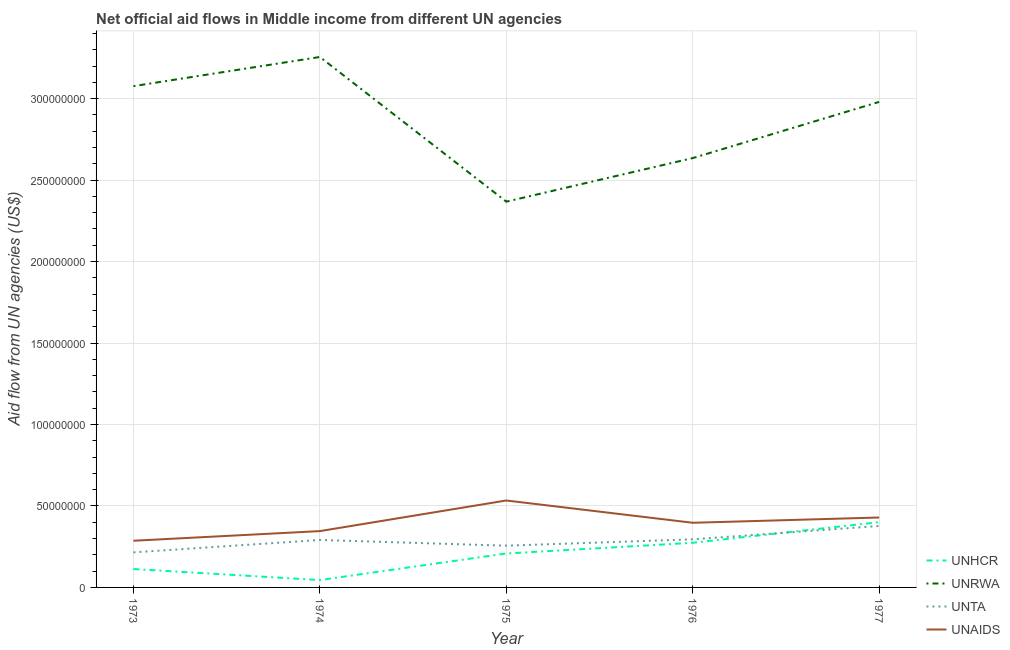How many different coloured lines are there?
Ensure brevity in your answer.  4. Does the line corresponding to amount of aid given by unrwa intersect with the line corresponding to amount of aid given by unhcr?
Offer a terse response. No. What is the amount of aid given by unta in 1975?
Offer a terse response. 2.56e+07. Across all years, what is the maximum amount of aid given by unta?
Give a very brief answer. 3.77e+07. Across all years, what is the minimum amount of aid given by unta?
Offer a very short reply. 2.15e+07. In which year was the amount of aid given by unta minimum?
Make the answer very short. 1973. What is the total amount of aid given by unrwa in the graph?
Offer a very short reply. 1.43e+09. What is the difference between the amount of aid given by unhcr in 1973 and that in 1975?
Make the answer very short. -9.52e+06. What is the difference between the amount of aid given by unaids in 1973 and the amount of aid given by unrwa in 1974?
Your response must be concise. -2.97e+08. What is the average amount of aid given by unrwa per year?
Make the answer very short. 2.86e+08. In the year 1975, what is the difference between the amount of aid given by unta and amount of aid given by unaids?
Your answer should be compact. -2.77e+07. In how many years, is the amount of aid given by unrwa greater than 40000000 US$?
Provide a short and direct response. 5. What is the ratio of the amount of aid given by unhcr in 1973 to that in 1977?
Give a very brief answer. 0.28. Is the amount of aid given by unrwa in 1973 less than that in 1977?
Make the answer very short. No. Is the difference between the amount of aid given by unta in 1975 and 1977 greater than the difference between the amount of aid given by unhcr in 1975 and 1977?
Your response must be concise. Yes. What is the difference between the highest and the second highest amount of aid given by unaids?
Make the answer very short. 1.04e+07. What is the difference between the highest and the lowest amount of aid given by unta?
Your answer should be very brief. 1.62e+07. Is the sum of the amount of aid given by unaids in 1973 and 1977 greater than the maximum amount of aid given by unrwa across all years?
Your response must be concise. No. Is it the case that in every year, the sum of the amount of aid given by unhcr and amount of aid given by unaids is greater than the sum of amount of aid given by unta and amount of aid given by unrwa?
Ensure brevity in your answer.  No. Is it the case that in every year, the sum of the amount of aid given by unhcr and amount of aid given by unrwa is greater than the amount of aid given by unta?
Offer a very short reply. Yes. Does the amount of aid given by unta monotonically increase over the years?
Offer a very short reply. No. Is the amount of aid given by unta strictly greater than the amount of aid given by unhcr over the years?
Provide a succinct answer. No. What is the difference between two consecutive major ticks on the Y-axis?
Give a very brief answer. 5.00e+07. Are the values on the major ticks of Y-axis written in scientific E-notation?
Your answer should be very brief. No. Where does the legend appear in the graph?
Offer a terse response. Bottom right. How many legend labels are there?
Give a very brief answer. 4. What is the title of the graph?
Your response must be concise. Net official aid flows in Middle income from different UN agencies. What is the label or title of the X-axis?
Keep it short and to the point. Year. What is the label or title of the Y-axis?
Give a very brief answer. Aid flow from UN agencies (US$). What is the Aid flow from UN agencies (US$) in UNHCR in 1973?
Ensure brevity in your answer.  1.13e+07. What is the Aid flow from UN agencies (US$) in UNRWA in 1973?
Your answer should be compact. 3.08e+08. What is the Aid flow from UN agencies (US$) in UNTA in 1973?
Ensure brevity in your answer.  2.15e+07. What is the Aid flow from UN agencies (US$) of UNAIDS in 1973?
Give a very brief answer. 2.87e+07. What is the Aid flow from UN agencies (US$) in UNHCR in 1974?
Offer a very short reply. 4.51e+06. What is the Aid flow from UN agencies (US$) of UNRWA in 1974?
Keep it short and to the point. 3.26e+08. What is the Aid flow from UN agencies (US$) in UNTA in 1974?
Make the answer very short. 2.91e+07. What is the Aid flow from UN agencies (US$) in UNAIDS in 1974?
Your answer should be very brief. 3.46e+07. What is the Aid flow from UN agencies (US$) in UNHCR in 1975?
Provide a short and direct response. 2.08e+07. What is the Aid flow from UN agencies (US$) in UNRWA in 1975?
Give a very brief answer. 2.37e+08. What is the Aid flow from UN agencies (US$) of UNTA in 1975?
Your response must be concise. 2.56e+07. What is the Aid flow from UN agencies (US$) of UNAIDS in 1975?
Your answer should be compact. 5.34e+07. What is the Aid flow from UN agencies (US$) in UNHCR in 1976?
Give a very brief answer. 2.74e+07. What is the Aid flow from UN agencies (US$) of UNRWA in 1976?
Your answer should be compact. 2.64e+08. What is the Aid flow from UN agencies (US$) in UNTA in 1976?
Give a very brief answer. 2.95e+07. What is the Aid flow from UN agencies (US$) in UNAIDS in 1976?
Your answer should be very brief. 3.97e+07. What is the Aid flow from UN agencies (US$) of UNHCR in 1977?
Make the answer very short. 4.01e+07. What is the Aid flow from UN agencies (US$) of UNRWA in 1977?
Your response must be concise. 2.98e+08. What is the Aid flow from UN agencies (US$) in UNTA in 1977?
Your answer should be compact. 3.77e+07. What is the Aid flow from UN agencies (US$) of UNAIDS in 1977?
Offer a very short reply. 4.29e+07. Across all years, what is the maximum Aid flow from UN agencies (US$) of UNHCR?
Provide a short and direct response. 4.01e+07. Across all years, what is the maximum Aid flow from UN agencies (US$) of UNRWA?
Offer a very short reply. 3.26e+08. Across all years, what is the maximum Aid flow from UN agencies (US$) in UNTA?
Ensure brevity in your answer.  3.77e+07. Across all years, what is the maximum Aid flow from UN agencies (US$) of UNAIDS?
Your answer should be very brief. 5.34e+07. Across all years, what is the minimum Aid flow from UN agencies (US$) of UNHCR?
Provide a short and direct response. 4.51e+06. Across all years, what is the minimum Aid flow from UN agencies (US$) of UNRWA?
Your answer should be compact. 2.37e+08. Across all years, what is the minimum Aid flow from UN agencies (US$) in UNTA?
Offer a very short reply. 2.15e+07. Across all years, what is the minimum Aid flow from UN agencies (US$) of UNAIDS?
Offer a terse response. 2.87e+07. What is the total Aid flow from UN agencies (US$) in UNHCR in the graph?
Provide a succinct answer. 1.04e+08. What is the total Aid flow from UN agencies (US$) of UNRWA in the graph?
Offer a terse response. 1.43e+09. What is the total Aid flow from UN agencies (US$) of UNTA in the graph?
Your answer should be compact. 1.44e+08. What is the total Aid flow from UN agencies (US$) of UNAIDS in the graph?
Provide a short and direct response. 1.99e+08. What is the difference between the Aid flow from UN agencies (US$) in UNHCR in 1973 and that in 1974?
Your answer should be very brief. 6.79e+06. What is the difference between the Aid flow from UN agencies (US$) of UNRWA in 1973 and that in 1974?
Provide a short and direct response. -1.79e+07. What is the difference between the Aid flow from UN agencies (US$) of UNTA in 1973 and that in 1974?
Your answer should be compact. -7.61e+06. What is the difference between the Aid flow from UN agencies (US$) of UNAIDS in 1973 and that in 1974?
Your answer should be compact. -5.91e+06. What is the difference between the Aid flow from UN agencies (US$) of UNHCR in 1973 and that in 1975?
Your answer should be very brief. -9.52e+06. What is the difference between the Aid flow from UN agencies (US$) in UNRWA in 1973 and that in 1975?
Provide a short and direct response. 7.09e+07. What is the difference between the Aid flow from UN agencies (US$) of UNTA in 1973 and that in 1975?
Offer a terse response. -4.10e+06. What is the difference between the Aid flow from UN agencies (US$) in UNAIDS in 1973 and that in 1975?
Provide a succinct answer. -2.47e+07. What is the difference between the Aid flow from UN agencies (US$) in UNHCR in 1973 and that in 1976?
Your answer should be very brief. -1.61e+07. What is the difference between the Aid flow from UN agencies (US$) of UNRWA in 1973 and that in 1976?
Ensure brevity in your answer.  4.42e+07. What is the difference between the Aid flow from UN agencies (US$) in UNTA in 1973 and that in 1976?
Offer a terse response. -8.01e+06. What is the difference between the Aid flow from UN agencies (US$) of UNAIDS in 1973 and that in 1976?
Your response must be concise. -1.10e+07. What is the difference between the Aid flow from UN agencies (US$) in UNHCR in 1973 and that in 1977?
Provide a short and direct response. -2.88e+07. What is the difference between the Aid flow from UN agencies (US$) in UNRWA in 1973 and that in 1977?
Give a very brief answer. 9.68e+06. What is the difference between the Aid flow from UN agencies (US$) in UNTA in 1973 and that in 1977?
Keep it short and to the point. -1.62e+07. What is the difference between the Aid flow from UN agencies (US$) in UNAIDS in 1973 and that in 1977?
Give a very brief answer. -1.43e+07. What is the difference between the Aid flow from UN agencies (US$) in UNHCR in 1974 and that in 1975?
Ensure brevity in your answer.  -1.63e+07. What is the difference between the Aid flow from UN agencies (US$) in UNRWA in 1974 and that in 1975?
Provide a short and direct response. 8.88e+07. What is the difference between the Aid flow from UN agencies (US$) of UNTA in 1974 and that in 1975?
Your response must be concise. 3.51e+06. What is the difference between the Aid flow from UN agencies (US$) in UNAIDS in 1974 and that in 1975?
Provide a succinct answer. -1.88e+07. What is the difference between the Aid flow from UN agencies (US$) of UNHCR in 1974 and that in 1976?
Provide a short and direct response. -2.29e+07. What is the difference between the Aid flow from UN agencies (US$) of UNRWA in 1974 and that in 1976?
Provide a succinct answer. 6.20e+07. What is the difference between the Aid flow from UN agencies (US$) in UNTA in 1974 and that in 1976?
Give a very brief answer. -4.00e+05. What is the difference between the Aid flow from UN agencies (US$) in UNAIDS in 1974 and that in 1976?
Give a very brief answer. -5.11e+06. What is the difference between the Aid flow from UN agencies (US$) in UNHCR in 1974 and that in 1977?
Provide a succinct answer. -3.56e+07. What is the difference between the Aid flow from UN agencies (US$) in UNRWA in 1974 and that in 1977?
Make the answer very short. 2.76e+07. What is the difference between the Aid flow from UN agencies (US$) of UNTA in 1974 and that in 1977?
Offer a very short reply. -8.60e+06. What is the difference between the Aid flow from UN agencies (US$) in UNAIDS in 1974 and that in 1977?
Keep it short and to the point. -8.35e+06. What is the difference between the Aid flow from UN agencies (US$) in UNHCR in 1975 and that in 1976?
Provide a succinct answer. -6.58e+06. What is the difference between the Aid flow from UN agencies (US$) of UNRWA in 1975 and that in 1976?
Your answer should be very brief. -2.67e+07. What is the difference between the Aid flow from UN agencies (US$) in UNTA in 1975 and that in 1976?
Keep it short and to the point. -3.91e+06. What is the difference between the Aid flow from UN agencies (US$) in UNAIDS in 1975 and that in 1976?
Your response must be concise. 1.37e+07. What is the difference between the Aid flow from UN agencies (US$) in UNHCR in 1975 and that in 1977?
Your response must be concise. -1.92e+07. What is the difference between the Aid flow from UN agencies (US$) in UNRWA in 1975 and that in 1977?
Your answer should be compact. -6.12e+07. What is the difference between the Aid flow from UN agencies (US$) in UNTA in 1975 and that in 1977?
Ensure brevity in your answer.  -1.21e+07. What is the difference between the Aid flow from UN agencies (US$) of UNAIDS in 1975 and that in 1977?
Ensure brevity in your answer.  1.04e+07. What is the difference between the Aid flow from UN agencies (US$) in UNHCR in 1976 and that in 1977?
Ensure brevity in your answer.  -1.27e+07. What is the difference between the Aid flow from UN agencies (US$) in UNRWA in 1976 and that in 1977?
Your response must be concise. -3.45e+07. What is the difference between the Aid flow from UN agencies (US$) in UNTA in 1976 and that in 1977?
Your answer should be very brief. -8.20e+06. What is the difference between the Aid flow from UN agencies (US$) of UNAIDS in 1976 and that in 1977?
Your answer should be very brief. -3.24e+06. What is the difference between the Aid flow from UN agencies (US$) of UNHCR in 1973 and the Aid flow from UN agencies (US$) of UNRWA in 1974?
Keep it short and to the point. -3.14e+08. What is the difference between the Aid flow from UN agencies (US$) of UNHCR in 1973 and the Aid flow from UN agencies (US$) of UNTA in 1974?
Offer a terse response. -1.78e+07. What is the difference between the Aid flow from UN agencies (US$) of UNHCR in 1973 and the Aid flow from UN agencies (US$) of UNAIDS in 1974?
Keep it short and to the point. -2.33e+07. What is the difference between the Aid flow from UN agencies (US$) in UNRWA in 1973 and the Aid flow from UN agencies (US$) in UNTA in 1974?
Provide a succinct answer. 2.79e+08. What is the difference between the Aid flow from UN agencies (US$) in UNRWA in 1973 and the Aid flow from UN agencies (US$) in UNAIDS in 1974?
Give a very brief answer. 2.73e+08. What is the difference between the Aid flow from UN agencies (US$) in UNTA in 1973 and the Aid flow from UN agencies (US$) in UNAIDS in 1974?
Provide a succinct answer. -1.30e+07. What is the difference between the Aid flow from UN agencies (US$) of UNHCR in 1973 and the Aid flow from UN agencies (US$) of UNRWA in 1975?
Ensure brevity in your answer.  -2.25e+08. What is the difference between the Aid flow from UN agencies (US$) in UNHCR in 1973 and the Aid flow from UN agencies (US$) in UNTA in 1975?
Make the answer very short. -1.43e+07. What is the difference between the Aid flow from UN agencies (US$) of UNHCR in 1973 and the Aid flow from UN agencies (US$) of UNAIDS in 1975?
Your answer should be compact. -4.21e+07. What is the difference between the Aid flow from UN agencies (US$) in UNRWA in 1973 and the Aid flow from UN agencies (US$) in UNTA in 1975?
Offer a terse response. 2.82e+08. What is the difference between the Aid flow from UN agencies (US$) of UNRWA in 1973 and the Aid flow from UN agencies (US$) of UNAIDS in 1975?
Provide a succinct answer. 2.54e+08. What is the difference between the Aid flow from UN agencies (US$) of UNTA in 1973 and the Aid flow from UN agencies (US$) of UNAIDS in 1975?
Offer a very short reply. -3.18e+07. What is the difference between the Aid flow from UN agencies (US$) in UNHCR in 1973 and the Aid flow from UN agencies (US$) in UNRWA in 1976?
Offer a terse response. -2.52e+08. What is the difference between the Aid flow from UN agencies (US$) of UNHCR in 1973 and the Aid flow from UN agencies (US$) of UNTA in 1976?
Give a very brief answer. -1.82e+07. What is the difference between the Aid flow from UN agencies (US$) of UNHCR in 1973 and the Aid flow from UN agencies (US$) of UNAIDS in 1976?
Keep it short and to the point. -2.84e+07. What is the difference between the Aid flow from UN agencies (US$) of UNRWA in 1973 and the Aid flow from UN agencies (US$) of UNTA in 1976?
Your answer should be compact. 2.78e+08. What is the difference between the Aid flow from UN agencies (US$) in UNRWA in 1973 and the Aid flow from UN agencies (US$) in UNAIDS in 1976?
Ensure brevity in your answer.  2.68e+08. What is the difference between the Aid flow from UN agencies (US$) in UNTA in 1973 and the Aid flow from UN agencies (US$) in UNAIDS in 1976?
Offer a terse response. -1.82e+07. What is the difference between the Aid flow from UN agencies (US$) of UNHCR in 1973 and the Aid flow from UN agencies (US$) of UNRWA in 1977?
Your answer should be compact. -2.87e+08. What is the difference between the Aid flow from UN agencies (US$) of UNHCR in 1973 and the Aid flow from UN agencies (US$) of UNTA in 1977?
Ensure brevity in your answer.  -2.64e+07. What is the difference between the Aid flow from UN agencies (US$) of UNHCR in 1973 and the Aid flow from UN agencies (US$) of UNAIDS in 1977?
Offer a terse response. -3.16e+07. What is the difference between the Aid flow from UN agencies (US$) of UNRWA in 1973 and the Aid flow from UN agencies (US$) of UNTA in 1977?
Provide a succinct answer. 2.70e+08. What is the difference between the Aid flow from UN agencies (US$) of UNRWA in 1973 and the Aid flow from UN agencies (US$) of UNAIDS in 1977?
Keep it short and to the point. 2.65e+08. What is the difference between the Aid flow from UN agencies (US$) in UNTA in 1973 and the Aid flow from UN agencies (US$) in UNAIDS in 1977?
Keep it short and to the point. -2.14e+07. What is the difference between the Aid flow from UN agencies (US$) of UNHCR in 1974 and the Aid flow from UN agencies (US$) of UNRWA in 1975?
Your answer should be very brief. -2.32e+08. What is the difference between the Aid flow from UN agencies (US$) in UNHCR in 1974 and the Aid flow from UN agencies (US$) in UNTA in 1975?
Your answer should be compact. -2.11e+07. What is the difference between the Aid flow from UN agencies (US$) of UNHCR in 1974 and the Aid flow from UN agencies (US$) of UNAIDS in 1975?
Your answer should be very brief. -4.88e+07. What is the difference between the Aid flow from UN agencies (US$) in UNRWA in 1974 and the Aid flow from UN agencies (US$) in UNTA in 1975?
Your answer should be compact. 3.00e+08. What is the difference between the Aid flow from UN agencies (US$) of UNRWA in 1974 and the Aid flow from UN agencies (US$) of UNAIDS in 1975?
Ensure brevity in your answer.  2.72e+08. What is the difference between the Aid flow from UN agencies (US$) of UNTA in 1974 and the Aid flow from UN agencies (US$) of UNAIDS in 1975?
Provide a short and direct response. -2.42e+07. What is the difference between the Aid flow from UN agencies (US$) in UNHCR in 1974 and the Aid flow from UN agencies (US$) in UNRWA in 1976?
Your answer should be compact. -2.59e+08. What is the difference between the Aid flow from UN agencies (US$) of UNHCR in 1974 and the Aid flow from UN agencies (US$) of UNTA in 1976?
Your response must be concise. -2.50e+07. What is the difference between the Aid flow from UN agencies (US$) of UNHCR in 1974 and the Aid flow from UN agencies (US$) of UNAIDS in 1976?
Provide a short and direct response. -3.52e+07. What is the difference between the Aid flow from UN agencies (US$) in UNRWA in 1974 and the Aid flow from UN agencies (US$) in UNTA in 1976?
Your answer should be compact. 2.96e+08. What is the difference between the Aid flow from UN agencies (US$) in UNRWA in 1974 and the Aid flow from UN agencies (US$) in UNAIDS in 1976?
Offer a very short reply. 2.86e+08. What is the difference between the Aid flow from UN agencies (US$) in UNTA in 1974 and the Aid flow from UN agencies (US$) in UNAIDS in 1976?
Ensure brevity in your answer.  -1.06e+07. What is the difference between the Aid flow from UN agencies (US$) in UNHCR in 1974 and the Aid flow from UN agencies (US$) in UNRWA in 1977?
Provide a succinct answer. -2.93e+08. What is the difference between the Aid flow from UN agencies (US$) in UNHCR in 1974 and the Aid flow from UN agencies (US$) in UNTA in 1977?
Your answer should be compact. -3.32e+07. What is the difference between the Aid flow from UN agencies (US$) of UNHCR in 1974 and the Aid flow from UN agencies (US$) of UNAIDS in 1977?
Give a very brief answer. -3.84e+07. What is the difference between the Aid flow from UN agencies (US$) in UNRWA in 1974 and the Aid flow from UN agencies (US$) in UNTA in 1977?
Your answer should be compact. 2.88e+08. What is the difference between the Aid flow from UN agencies (US$) of UNRWA in 1974 and the Aid flow from UN agencies (US$) of UNAIDS in 1977?
Offer a terse response. 2.83e+08. What is the difference between the Aid flow from UN agencies (US$) in UNTA in 1974 and the Aid flow from UN agencies (US$) in UNAIDS in 1977?
Give a very brief answer. -1.38e+07. What is the difference between the Aid flow from UN agencies (US$) of UNHCR in 1975 and the Aid flow from UN agencies (US$) of UNRWA in 1976?
Offer a terse response. -2.43e+08. What is the difference between the Aid flow from UN agencies (US$) of UNHCR in 1975 and the Aid flow from UN agencies (US$) of UNTA in 1976?
Offer a very short reply. -8.71e+06. What is the difference between the Aid flow from UN agencies (US$) in UNHCR in 1975 and the Aid flow from UN agencies (US$) in UNAIDS in 1976?
Your answer should be very brief. -1.89e+07. What is the difference between the Aid flow from UN agencies (US$) of UNRWA in 1975 and the Aid flow from UN agencies (US$) of UNTA in 1976?
Provide a succinct answer. 2.07e+08. What is the difference between the Aid flow from UN agencies (US$) in UNRWA in 1975 and the Aid flow from UN agencies (US$) in UNAIDS in 1976?
Ensure brevity in your answer.  1.97e+08. What is the difference between the Aid flow from UN agencies (US$) in UNTA in 1975 and the Aid flow from UN agencies (US$) in UNAIDS in 1976?
Make the answer very short. -1.41e+07. What is the difference between the Aid flow from UN agencies (US$) in UNHCR in 1975 and the Aid flow from UN agencies (US$) in UNRWA in 1977?
Provide a succinct answer. -2.77e+08. What is the difference between the Aid flow from UN agencies (US$) of UNHCR in 1975 and the Aid flow from UN agencies (US$) of UNTA in 1977?
Your response must be concise. -1.69e+07. What is the difference between the Aid flow from UN agencies (US$) in UNHCR in 1975 and the Aid flow from UN agencies (US$) in UNAIDS in 1977?
Provide a succinct answer. -2.21e+07. What is the difference between the Aid flow from UN agencies (US$) of UNRWA in 1975 and the Aid flow from UN agencies (US$) of UNTA in 1977?
Offer a terse response. 1.99e+08. What is the difference between the Aid flow from UN agencies (US$) of UNRWA in 1975 and the Aid flow from UN agencies (US$) of UNAIDS in 1977?
Your answer should be very brief. 1.94e+08. What is the difference between the Aid flow from UN agencies (US$) of UNTA in 1975 and the Aid flow from UN agencies (US$) of UNAIDS in 1977?
Offer a terse response. -1.73e+07. What is the difference between the Aid flow from UN agencies (US$) of UNHCR in 1976 and the Aid flow from UN agencies (US$) of UNRWA in 1977?
Offer a terse response. -2.71e+08. What is the difference between the Aid flow from UN agencies (US$) in UNHCR in 1976 and the Aid flow from UN agencies (US$) in UNTA in 1977?
Provide a succinct answer. -1.03e+07. What is the difference between the Aid flow from UN agencies (US$) of UNHCR in 1976 and the Aid flow from UN agencies (US$) of UNAIDS in 1977?
Your answer should be compact. -1.55e+07. What is the difference between the Aid flow from UN agencies (US$) in UNRWA in 1976 and the Aid flow from UN agencies (US$) in UNTA in 1977?
Make the answer very short. 2.26e+08. What is the difference between the Aid flow from UN agencies (US$) in UNRWA in 1976 and the Aid flow from UN agencies (US$) in UNAIDS in 1977?
Your answer should be very brief. 2.21e+08. What is the difference between the Aid flow from UN agencies (US$) of UNTA in 1976 and the Aid flow from UN agencies (US$) of UNAIDS in 1977?
Your response must be concise. -1.34e+07. What is the average Aid flow from UN agencies (US$) of UNHCR per year?
Offer a terse response. 2.08e+07. What is the average Aid flow from UN agencies (US$) of UNRWA per year?
Give a very brief answer. 2.86e+08. What is the average Aid flow from UN agencies (US$) in UNTA per year?
Give a very brief answer. 2.87e+07. What is the average Aid flow from UN agencies (US$) of UNAIDS per year?
Provide a short and direct response. 3.98e+07. In the year 1973, what is the difference between the Aid flow from UN agencies (US$) in UNHCR and Aid flow from UN agencies (US$) in UNRWA?
Provide a short and direct response. -2.96e+08. In the year 1973, what is the difference between the Aid flow from UN agencies (US$) in UNHCR and Aid flow from UN agencies (US$) in UNTA?
Offer a terse response. -1.02e+07. In the year 1973, what is the difference between the Aid flow from UN agencies (US$) in UNHCR and Aid flow from UN agencies (US$) in UNAIDS?
Keep it short and to the point. -1.74e+07. In the year 1973, what is the difference between the Aid flow from UN agencies (US$) of UNRWA and Aid flow from UN agencies (US$) of UNTA?
Offer a terse response. 2.86e+08. In the year 1973, what is the difference between the Aid flow from UN agencies (US$) in UNRWA and Aid flow from UN agencies (US$) in UNAIDS?
Give a very brief answer. 2.79e+08. In the year 1973, what is the difference between the Aid flow from UN agencies (US$) in UNTA and Aid flow from UN agencies (US$) in UNAIDS?
Your answer should be compact. -7.14e+06. In the year 1974, what is the difference between the Aid flow from UN agencies (US$) of UNHCR and Aid flow from UN agencies (US$) of UNRWA?
Provide a short and direct response. -3.21e+08. In the year 1974, what is the difference between the Aid flow from UN agencies (US$) in UNHCR and Aid flow from UN agencies (US$) in UNTA?
Your response must be concise. -2.46e+07. In the year 1974, what is the difference between the Aid flow from UN agencies (US$) in UNHCR and Aid flow from UN agencies (US$) in UNAIDS?
Provide a succinct answer. -3.01e+07. In the year 1974, what is the difference between the Aid flow from UN agencies (US$) in UNRWA and Aid flow from UN agencies (US$) in UNTA?
Give a very brief answer. 2.96e+08. In the year 1974, what is the difference between the Aid flow from UN agencies (US$) in UNRWA and Aid flow from UN agencies (US$) in UNAIDS?
Give a very brief answer. 2.91e+08. In the year 1974, what is the difference between the Aid flow from UN agencies (US$) in UNTA and Aid flow from UN agencies (US$) in UNAIDS?
Give a very brief answer. -5.44e+06. In the year 1975, what is the difference between the Aid flow from UN agencies (US$) of UNHCR and Aid flow from UN agencies (US$) of UNRWA?
Your response must be concise. -2.16e+08. In the year 1975, what is the difference between the Aid flow from UN agencies (US$) in UNHCR and Aid flow from UN agencies (US$) in UNTA?
Give a very brief answer. -4.80e+06. In the year 1975, what is the difference between the Aid flow from UN agencies (US$) of UNHCR and Aid flow from UN agencies (US$) of UNAIDS?
Provide a short and direct response. -3.25e+07. In the year 1975, what is the difference between the Aid flow from UN agencies (US$) of UNRWA and Aid flow from UN agencies (US$) of UNTA?
Offer a terse response. 2.11e+08. In the year 1975, what is the difference between the Aid flow from UN agencies (US$) of UNRWA and Aid flow from UN agencies (US$) of UNAIDS?
Make the answer very short. 1.83e+08. In the year 1975, what is the difference between the Aid flow from UN agencies (US$) in UNTA and Aid flow from UN agencies (US$) in UNAIDS?
Make the answer very short. -2.77e+07. In the year 1976, what is the difference between the Aid flow from UN agencies (US$) in UNHCR and Aid flow from UN agencies (US$) in UNRWA?
Offer a very short reply. -2.36e+08. In the year 1976, what is the difference between the Aid flow from UN agencies (US$) of UNHCR and Aid flow from UN agencies (US$) of UNTA?
Give a very brief answer. -2.13e+06. In the year 1976, what is the difference between the Aid flow from UN agencies (US$) of UNHCR and Aid flow from UN agencies (US$) of UNAIDS?
Make the answer very short. -1.23e+07. In the year 1976, what is the difference between the Aid flow from UN agencies (US$) of UNRWA and Aid flow from UN agencies (US$) of UNTA?
Your answer should be very brief. 2.34e+08. In the year 1976, what is the difference between the Aid flow from UN agencies (US$) in UNRWA and Aid flow from UN agencies (US$) in UNAIDS?
Give a very brief answer. 2.24e+08. In the year 1976, what is the difference between the Aid flow from UN agencies (US$) in UNTA and Aid flow from UN agencies (US$) in UNAIDS?
Make the answer very short. -1.02e+07. In the year 1977, what is the difference between the Aid flow from UN agencies (US$) of UNHCR and Aid flow from UN agencies (US$) of UNRWA?
Provide a succinct answer. -2.58e+08. In the year 1977, what is the difference between the Aid flow from UN agencies (US$) of UNHCR and Aid flow from UN agencies (US$) of UNTA?
Offer a terse response. 2.33e+06. In the year 1977, what is the difference between the Aid flow from UN agencies (US$) in UNHCR and Aid flow from UN agencies (US$) in UNAIDS?
Make the answer very short. -2.86e+06. In the year 1977, what is the difference between the Aid flow from UN agencies (US$) of UNRWA and Aid flow from UN agencies (US$) of UNTA?
Provide a short and direct response. 2.60e+08. In the year 1977, what is the difference between the Aid flow from UN agencies (US$) in UNRWA and Aid flow from UN agencies (US$) in UNAIDS?
Keep it short and to the point. 2.55e+08. In the year 1977, what is the difference between the Aid flow from UN agencies (US$) of UNTA and Aid flow from UN agencies (US$) of UNAIDS?
Give a very brief answer. -5.19e+06. What is the ratio of the Aid flow from UN agencies (US$) in UNHCR in 1973 to that in 1974?
Keep it short and to the point. 2.51. What is the ratio of the Aid flow from UN agencies (US$) of UNRWA in 1973 to that in 1974?
Make the answer very short. 0.95. What is the ratio of the Aid flow from UN agencies (US$) in UNTA in 1973 to that in 1974?
Provide a short and direct response. 0.74. What is the ratio of the Aid flow from UN agencies (US$) in UNAIDS in 1973 to that in 1974?
Your answer should be compact. 0.83. What is the ratio of the Aid flow from UN agencies (US$) of UNHCR in 1973 to that in 1975?
Your response must be concise. 0.54. What is the ratio of the Aid flow from UN agencies (US$) in UNRWA in 1973 to that in 1975?
Your answer should be very brief. 1.3. What is the ratio of the Aid flow from UN agencies (US$) of UNTA in 1973 to that in 1975?
Ensure brevity in your answer.  0.84. What is the ratio of the Aid flow from UN agencies (US$) of UNAIDS in 1973 to that in 1975?
Offer a very short reply. 0.54. What is the ratio of the Aid flow from UN agencies (US$) of UNHCR in 1973 to that in 1976?
Provide a succinct answer. 0.41. What is the ratio of the Aid flow from UN agencies (US$) in UNRWA in 1973 to that in 1976?
Give a very brief answer. 1.17. What is the ratio of the Aid flow from UN agencies (US$) in UNTA in 1973 to that in 1976?
Offer a very short reply. 0.73. What is the ratio of the Aid flow from UN agencies (US$) in UNAIDS in 1973 to that in 1976?
Your answer should be compact. 0.72. What is the ratio of the Aid flow from UN agencies (US$) of UNHCR in 1973 to that in 1977?
Ensure brevity in your answer.  0.28. What is the ratio of the Aid flow from UN agencies (US$) of UNRWA in 1973 to that in 1977?
Offer a terse response. 1.03. What is the ratio of the Aid flow from UN agencies (US$) of UNTA in 1973 to that in 1977?
Provide a succinct answer. 0.57. What is the ratio of the Aid flow from UN agencies (US$) of UNAIDS in 1973 to that in 1977?
Ensure brevity in your answer.  0.67. What is the ratio of the Aid flow from UN agencies (US$) of UNHCR in 1974 to that in 1975?
Give a very brief answer. 0.22. What is the ratio of the Aid flow from UN agencies (US$) of UNRWA in 1974 to that in 1975?
Your answer should be compact. 1.38. What is the ratio of the Aid flow from UN agencies (US$) of UNTA in 1974 to that in 1975?
Give a very brief answer. 1.14. What is the ratio of the Aid flow from UN agencies (US$) in UNAIDS in 1974 to that in 1975?
Offer a very short reply. 0.65. What is the ratio of the Aid flow from UN agencies (US$) of UNHCR in 1974 to that in 1976?
Your answer should be very brief. 0.16. What is the ratio of the Aid flow from UN agencies (US$) of UNRWA in 1974 to that in 1976?
Provide a succinct answer. 1.24. What is the ratio of the Aid flow from UN agencies (US$) of UNTA in 1974 to that in 1976?
Provide a succinct answer. 0.99. What is the ratio of the Aid flow from UN agencies (US$) of UNAIDS in 1974 to that in 1976?
Give a very brief answer. 0.87. What is the ratio of the Aid flow from UN agencies (US$) of UNHCR in 1974 to that in 1977?
Ensure brevity in your answer.  0.11. What is the ratio of the Aid flow from UN agencies (US$) of UNRWA in 1974 to that in 1977?
Your answer should be very brief. 1.09. What is the ratio of the Aid flow from UN agencies (US$) in UNTA in 1974 to that in 1977?
Provide a succinct answer. 0.77. What is the ratio of the Aid flow from UN agencies (US$) of UNAIDS in 1974 to that in 1977?
Your response must be concise. 0.81. What is the ratio of the Aid flow from UN agencies (US$) in UNHCR in 1975 to that in 1976?
Offer a very short reply. 0.76. What is the ratio of the Aid flow from UN agencies (US$) in UNRWA in 1975 to that in 1976?
Offer a terse response. 0.9. What is the ratio of the Aid flow from UN agencies (US$) of UNTA in 1975 to that in 1976?
Give a very brief answer. 0.87. What is the ratio of the Aid flow from UN agencies (US$) in UNAIDS in 1975 to that in 1976?
Offer a very short reply. 1.34. What is the ratio of the Aid flow from UN agencies (US$) in UNHCR in 1975 to that in 1977?
Ensure brevity in your answer.  0.52. What is the ratio of the Aid flow from UN agencies (US$) in UNRWA in 1975 to that in 1977?
Provide a succinct answer. 0.79. What is the ratio of the Aid flow from UN agencies (US$) of UNTA in 1975 to that in 1977?
Your response must be concise. 0.68. What is the ratio of the Aid flow from UN agencies (US$) of UNAIDS in 1975 to that in 1977?
Ensure brevity in your answer.  1.24. What is the ratio of the Aid flow from UN agencies (US$) of UNHCR in 1976 to that in 1977?
Ensure brevity in your answer.  0.68. What is the ratio of the Aid flow from UN agencies (US$) of UNRWA in 1976 to that in 1977?
Provide a succinct answer. 0.88. What is the ratio of the Aid flow from UN agencies (US$) of UNTA in 1976 to that in 1977?
Your answer should be compact. 0.78. What is the ratio of the Aid flow from UN agencies (US$) of UNAIDS in 1976 to that in 1977?
Provide a succinct answer. 0.92. What is the difference between the highest and the second highest Aid flow from UN agencies (US$) of UNHCR?
Provide a succinct answer. 1.27e+07. What is the difference between the highest and the second highest Aid flow from UN agencies (US$) of UNRWA?
Offer a very short reply. 1.79e+07. What is the difference between the highest and the second highest Aid flow from UN agencies (US$) of UNTA?
Provide a succinct answer. 8.20e+06. What is the difference between the highest and the second highest Aid flow from UN agencies (US$) in UNAIDS?
Provide a short and direct response. 1.04e+07. What is the difference between the highest and the lowest Aid flow from UN agencies (US$) in UNHCR?
Your answer should be compact. 3.56e+07. What is the difference between the highest and the lowest Aid flow from UN agencies (US$) in UNRWA?
Provide a succinct answer. 8.88e+07. What is the difference between the highest and the lowest Aid flow from UN agencies (US$) of UNTA?
Keep it short and to the point. 1.62e+07. What is the difference between the highest and the lowest Aid flow from UN agencies (US$) of UNAIDS?
Make the answer very short. 2.47e+07. 